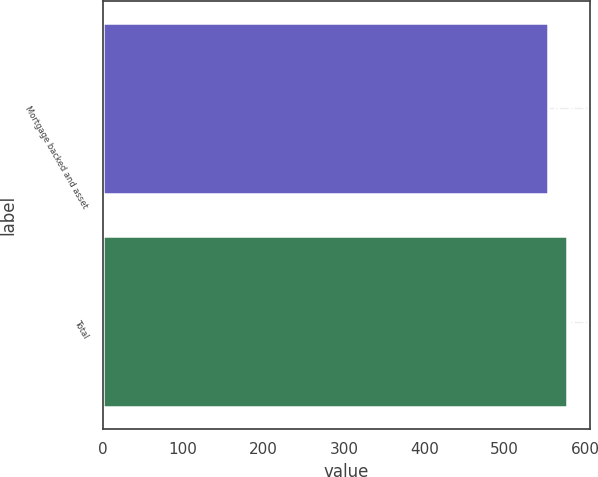<chart> <loc_0><loc_0><loc_500><loc_500><bar_chart><fcel>Mortgage backed and asset<fcel>Total<nl><fcel>554<fcel>577<nl></chart> 